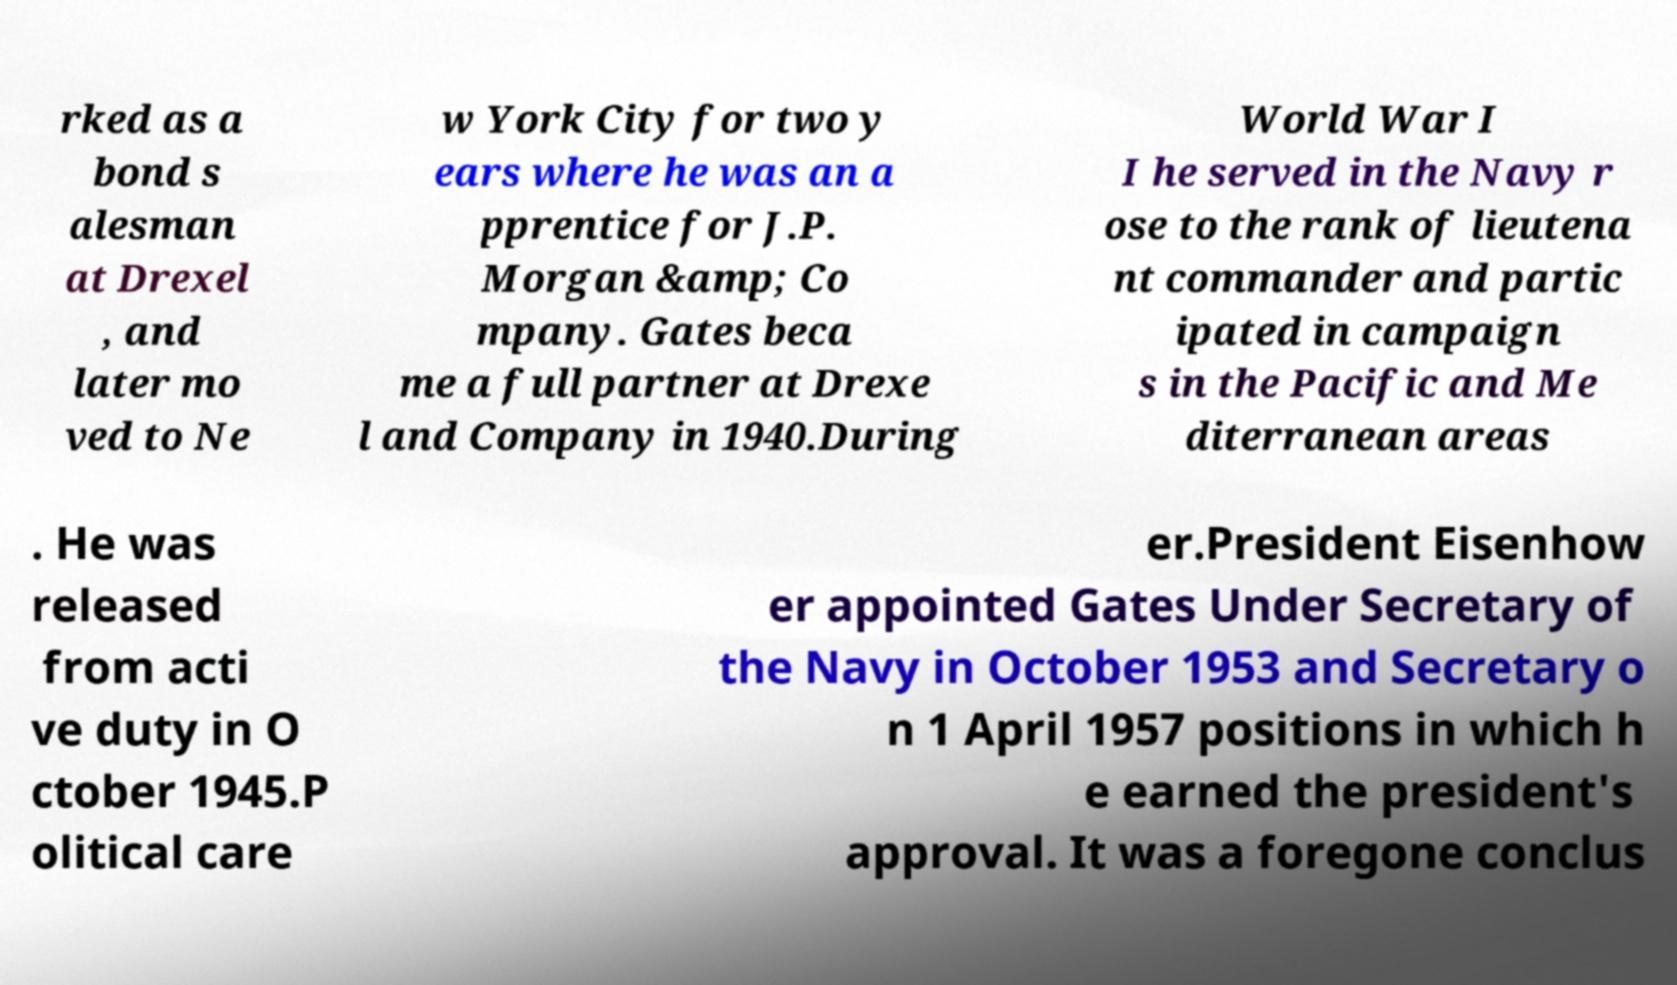For documentation purposes, I need the text within this image transcribed. Could you provide that? rked as a bond s alesman at Drexel , and later mo ved to Ne w York City for two y ears where he was an a pprentice for J.P. Morgan &amp; Co mpany. Gates beca me a full partner at Drexe l and Company in 1940.During World War I I he served in the Navy r ose to the rank of lieutena nt commander and partic ipated in campaign s in the Pacific and Me diterranean areas . He was released from acti ve duty in O ctober 1945.P olitical care er.President Eisenhow er appointed Gates Under Secretary of the Navy in October 1953 and Secretary o n 1 April 1957 positions in which h e earned the president's approval. It was a foregone conclus 